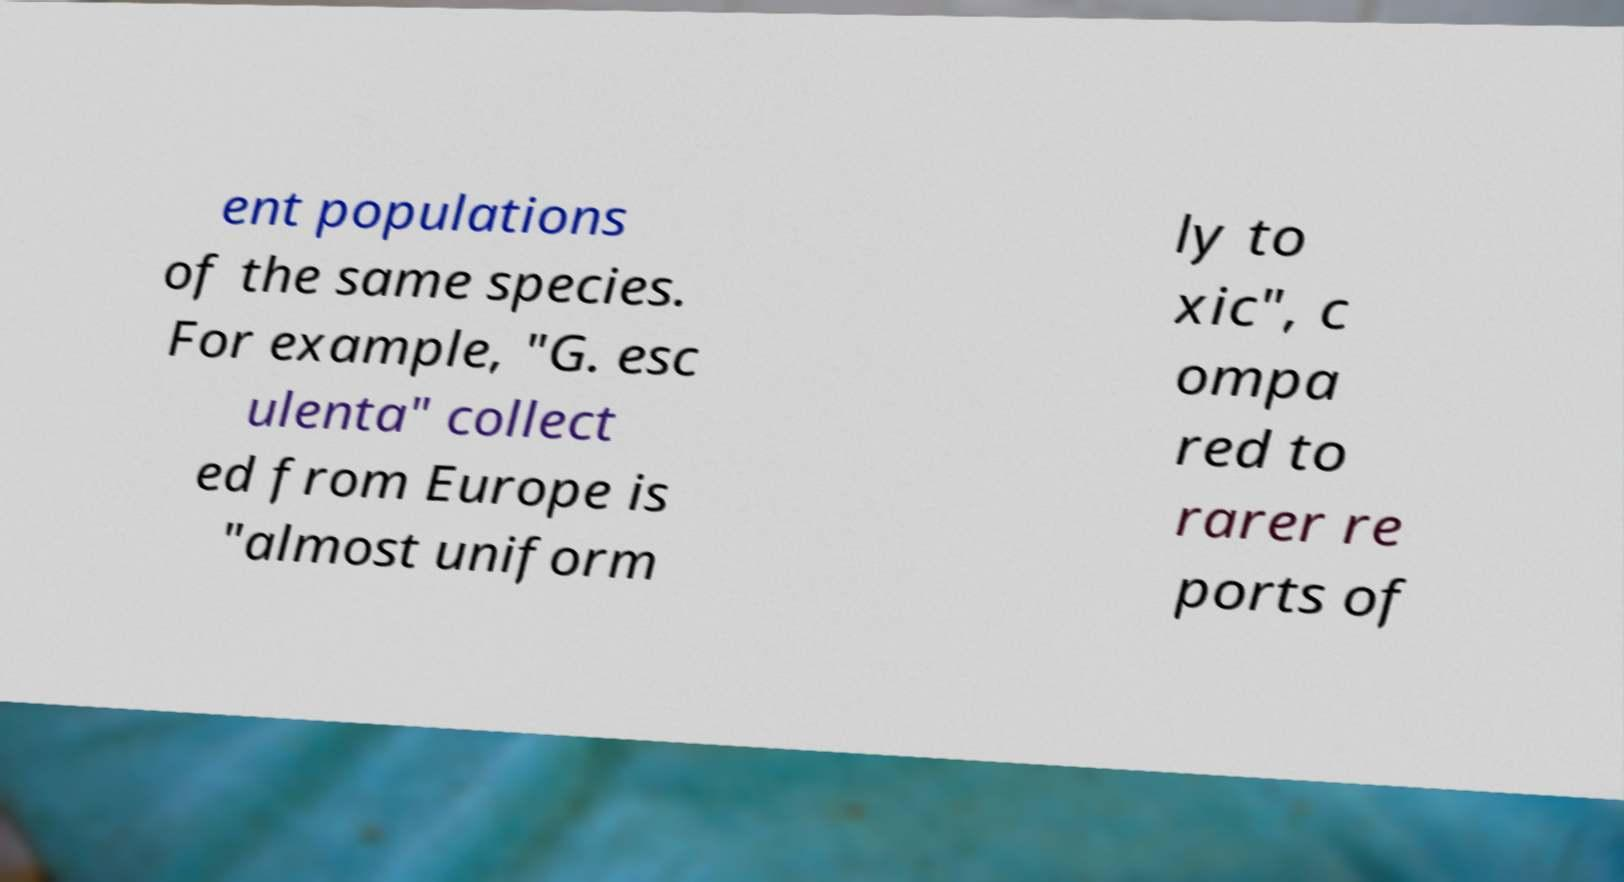Can you accurately transcribe the text from the provided image for me? ent populations of the same species. For example, "G. esc ulenta" collect ed from Europe is "almost uniform ly to xic", c ompa red to rarer re ports of 